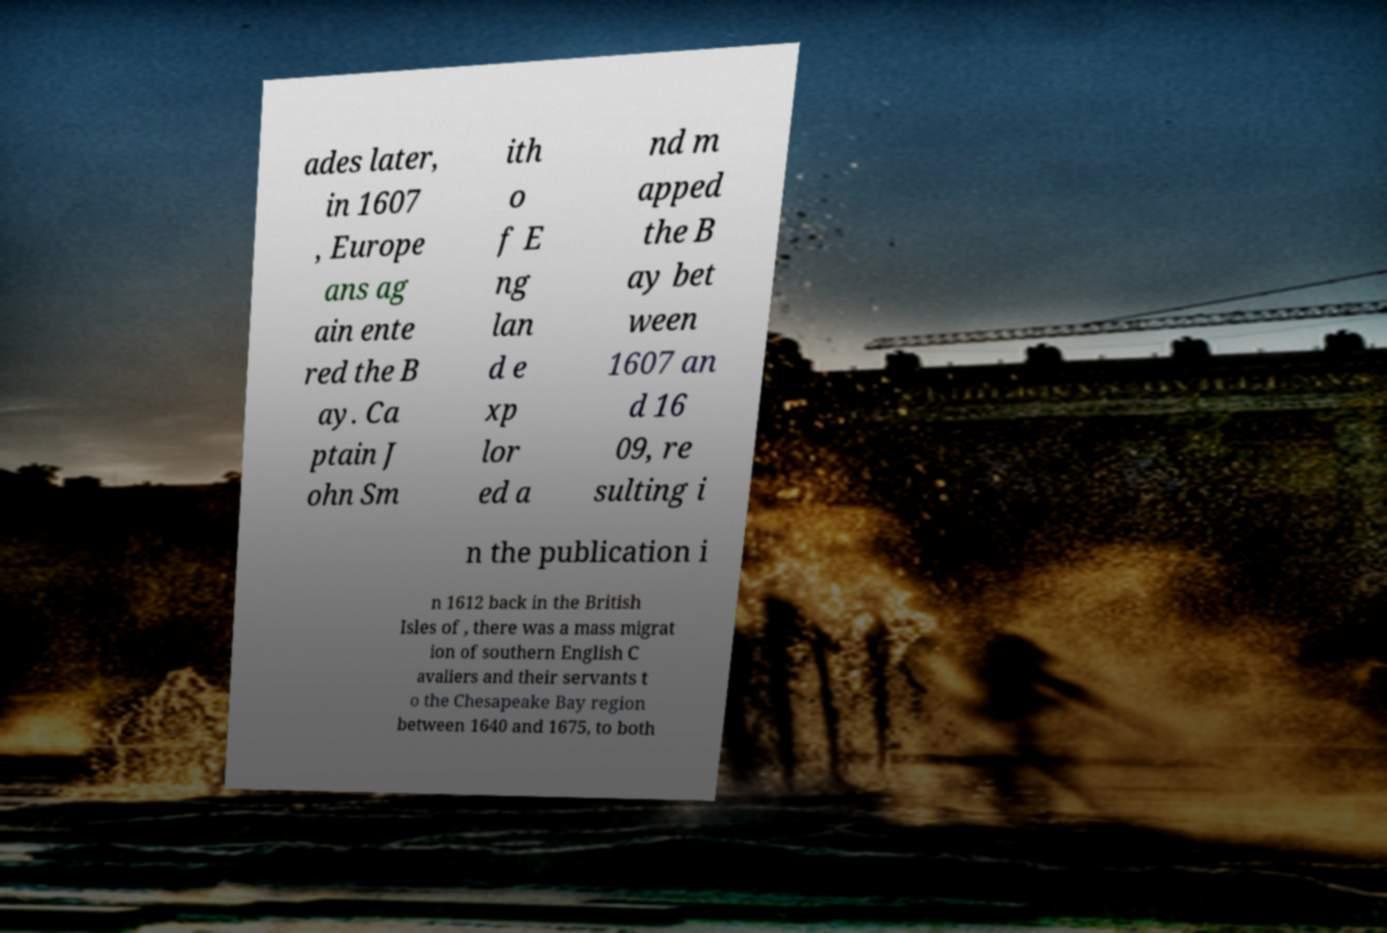Please identify and transcribe the text found in this image. ades later, in 1607 , Europe ans ag ain ente red the B ay. Ca ptain J ohn Sm ith o f E ng lan d e xp lor ed a nd m apped the B ay bet ween 1607 an d 16 09, re sulting i n the publication i n 1612 back in the British Isles of , there was a mass migrat ion of southern English C avaliers and their servants t o the Chesapeake Bay region between 1640 and 1675, to both 